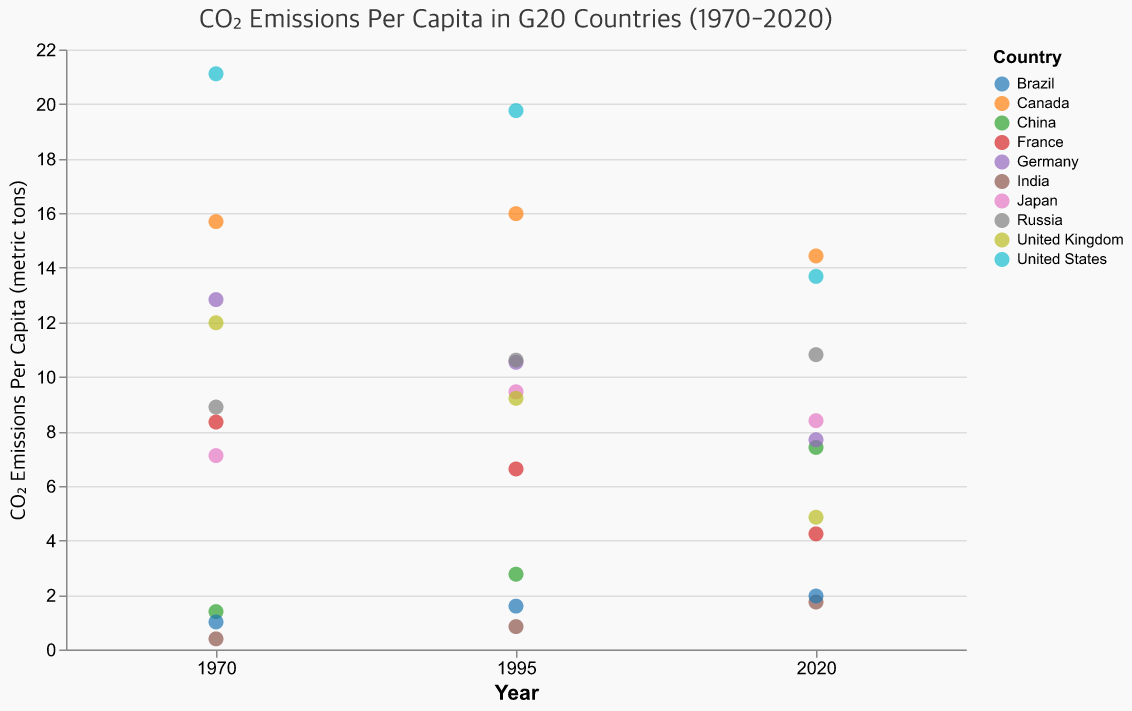What is the title of the plot? The title is located at the top of the figure, in the center. It reads "CO₂ Emissions Per Capita in G20 Countries (1970-2020)"
Answer: CO₂ Emissions Per Capita in G20 Countries (1970-2020) Which country had the highest CO2 emissions per capita in 1970? Looking at the y-axis values corresponding to the 1970 mark, the highest point aligns with the United States at 21.11 metric tons
Answer: United States How have CO2 emissions per capita changed in China from 1970 to 2020? By observing the points for China, CO2 emissions increased from 1.39 metric tons in 1970 to 7.41 metric tons in 2020
Answer: Increased from 1.39 to 7.41 metric tons What is the general trend of CO2 emissions per capita for Germany from 1970 to 2020? Observing the points for Germany across the years, there's a general decrease from 12.83 to 7.69 metric tons from 1970 to 2020
Answer: Decreasing trend Which two countries had almost equal CO2 emissions per capita in 2020? Looking at the y-axis values for 2020, Germany (7.69) and China (7.41) had very close CO2 emissions per capita
Answer: Germany and China What is the difference in CO2 emissions per capita between the United States and India in 1995? From the y-axis in 1995, the United States had 19.76 and India had 0.84, hence the difference is 19.76 - 0.84 = 18.92 metric tons
Answer: 18.92 metric tons Which country experienced the least change in CO2 emissions per capita from 1970 to 2020? Comparing the changes for each country between 1970 and 2020, Russia had a slight increase from 8.89 to 10.81, showing the least variation
Answer: Russia How many countries had a reduction in CO2 emissions per capita from 1970 to 2020? By assessing each country's data over the years, the United States, Germany, France, and the United Kingdom had reductions
Answer: Four countries What is the average CO2 emissions per capita for the United Kingdom over the three periods (1970, 1995, 2020)? Adding the values (11.98 + 9.21 + 4.85) and dividing by 3, we get the average (11.98 + 9.21 + 4.85) / 3 = 8.01 metric tons
Answer: 8.01 metric tons 